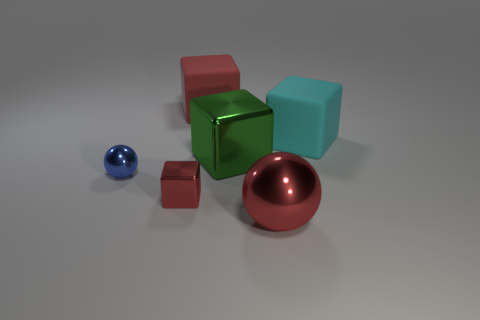Subtract all green metal cubes. How many cubes are left? 3 Subtract all green cubes. How many cubes are left? 3 Subtract all balls. How many objects are left? 4 Subtract all yellow cylinders. How many red blocks are left? 2 Add 3 large green rubber things. How many objects exist? 9 Subtract 4 cubes. How many cubes are left? 0 Subtract 2 red cubes. How many objects are left? 4 Subtract all blue balls. Subtract all cyan cylinders. How many balls are left? 1 Subtract all big blue cylinders. Subtract all small blue objects. How many objects are left? 5 Add 2 small blue shiny objects. How many small blue shiny objects are left? 3 